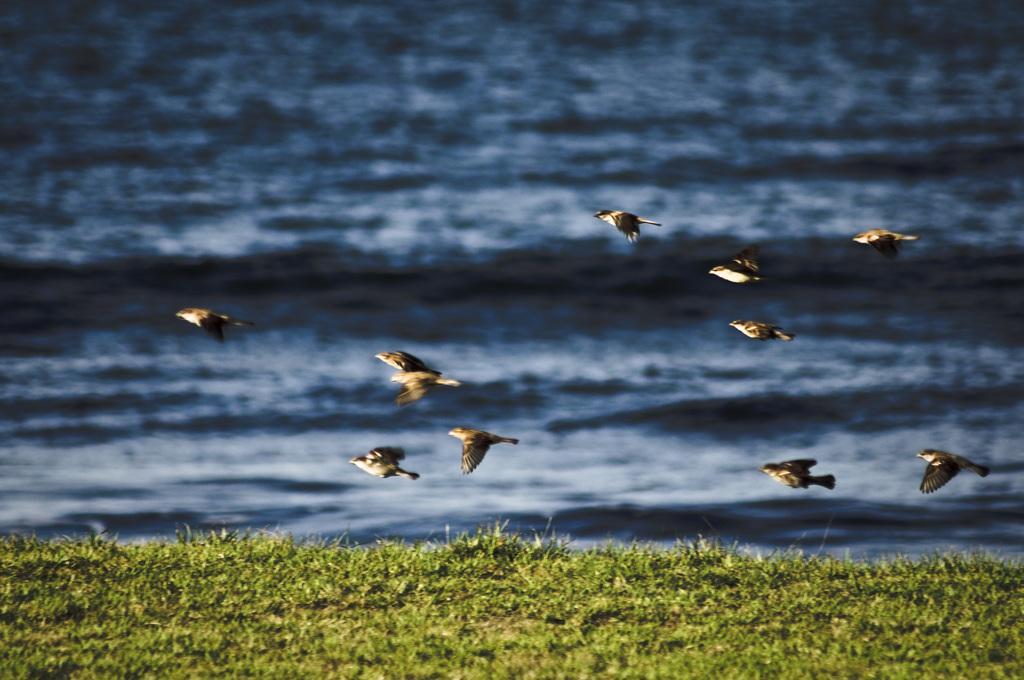How would you summarize this image in a sentence or two? In this image we an see some birds flying, also we can see the grass, and the water. 